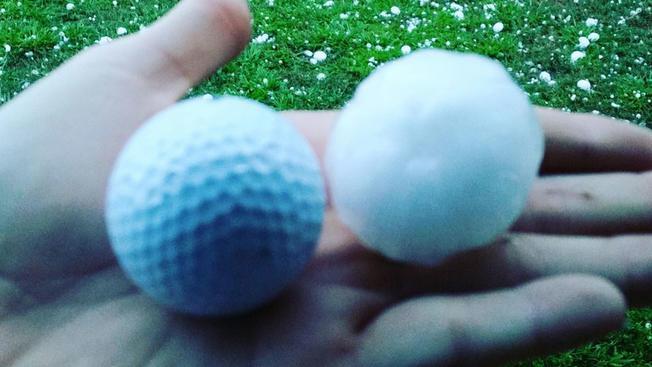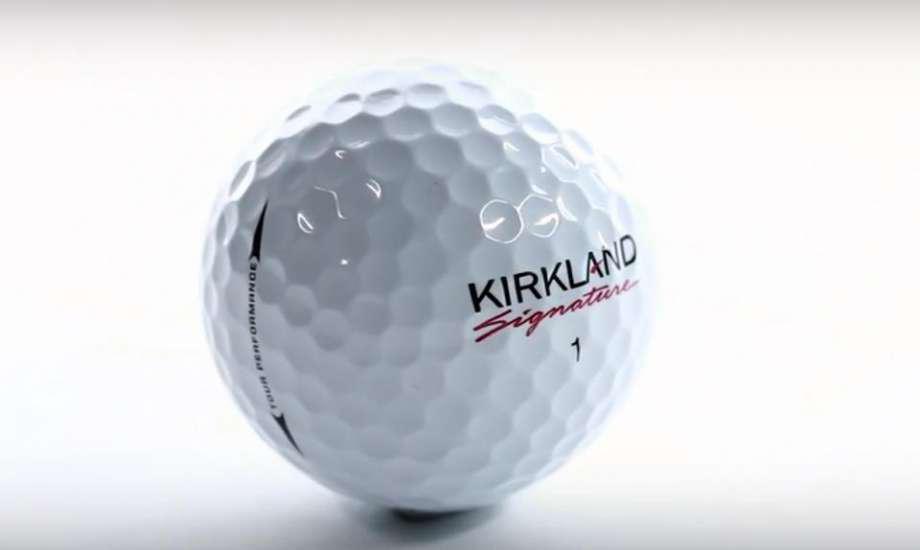The first image is the image on the left, the second image is the image on the right. Evaluate the accuracy of this statement regarding the images: "Part of a hand is touching one real golf ball in the lefthand image.". Is it true? Answer yes or no. Yes. The first image is the image on the left, the second image is the image on the right. Given the left and right images, does the statement "The left and right image contains the same number of golf balls with at least one in a person's hand." hold true? Answer yes or no. Yes. 